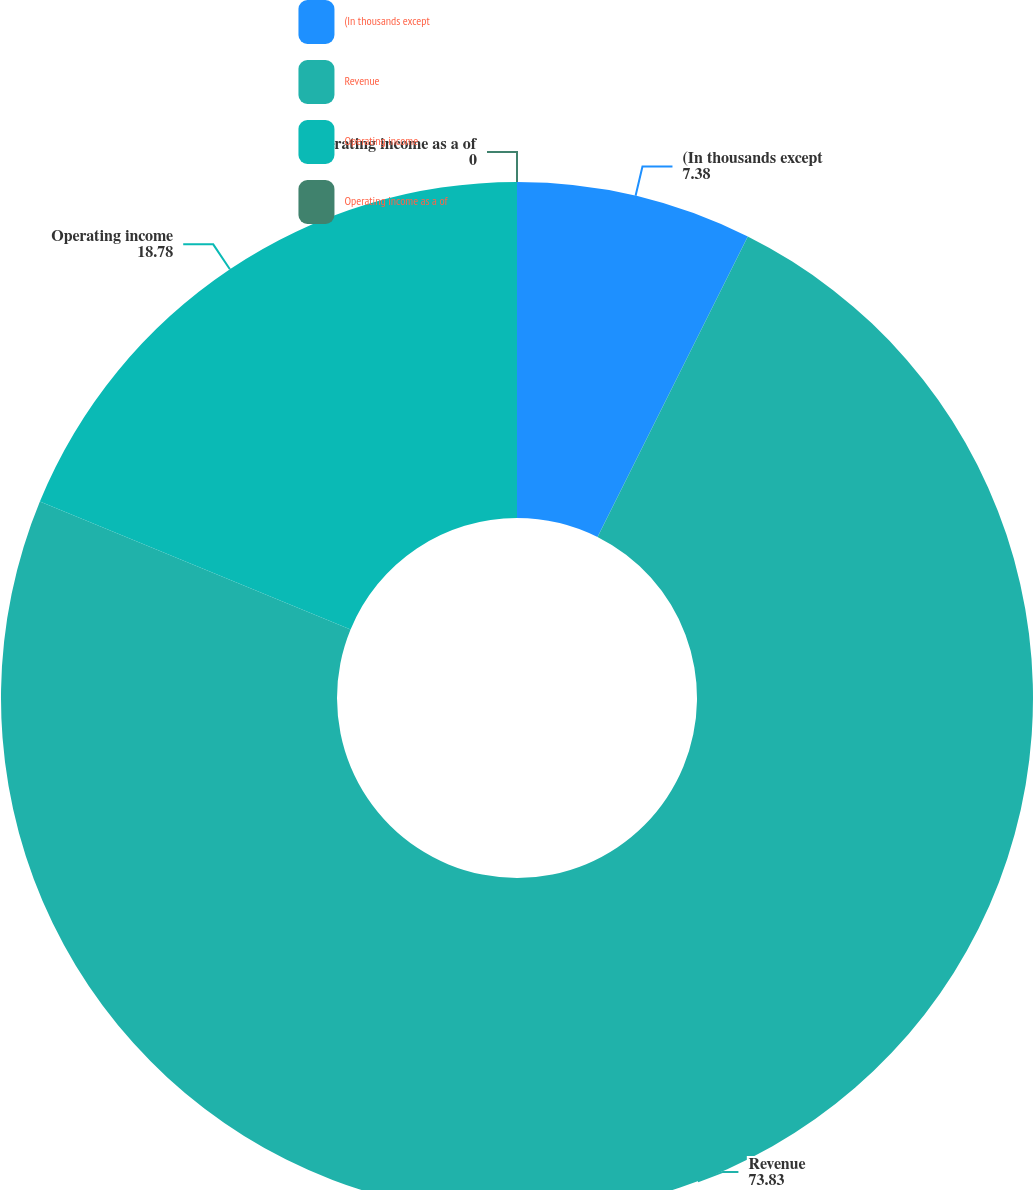Convert chart to OTSL. <chart><loc_0><loc_0><loc_500><loc_500><pie_chart><fcel>(In thousands except<fcel>Revenue<fcel>Operating income<fcel>Operating income as a of<nl><fcel>7.38%<fcel>73.83%<fcel>18.78%<fcel>0.0%<nl></chart> 